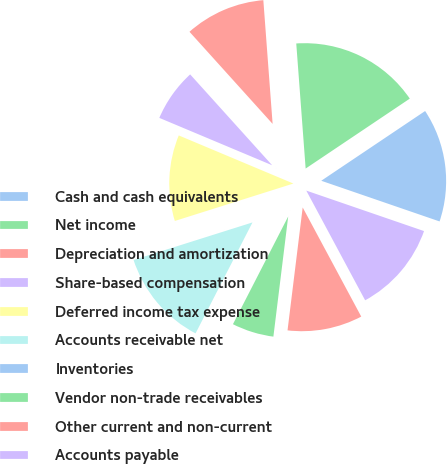<chart> <loc_0><loc_0><loc_500><loc_500><pie_chart><fcel>Cash and cash equivalents<fcel>Net income<fcel>Depreciation and amortization<fcel>Share-based compensation<fcel>Deferred income tax expense<fcel>Accounts receivable net<fcel>Inventories<fcel>Vendor non-trade receivables<fcel>Other current and non-current<fcel>Accounts payable<nl><fcel>14.68%<fcel>16.78%<fcel>10.49%<fcel>6.99%<fcel>11.19%<fcel>12.59%<fcel>0.0%<fcel>5.59%<fcel>9.79%<fcel>11.89%<nl></chart> 